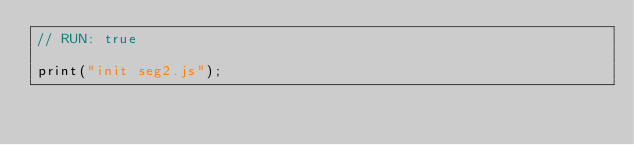<code> <loc_0><loc_0><loc_500><loc_500><_JavaScript_>// RUN: true

print("init seg2.js");
</code> 